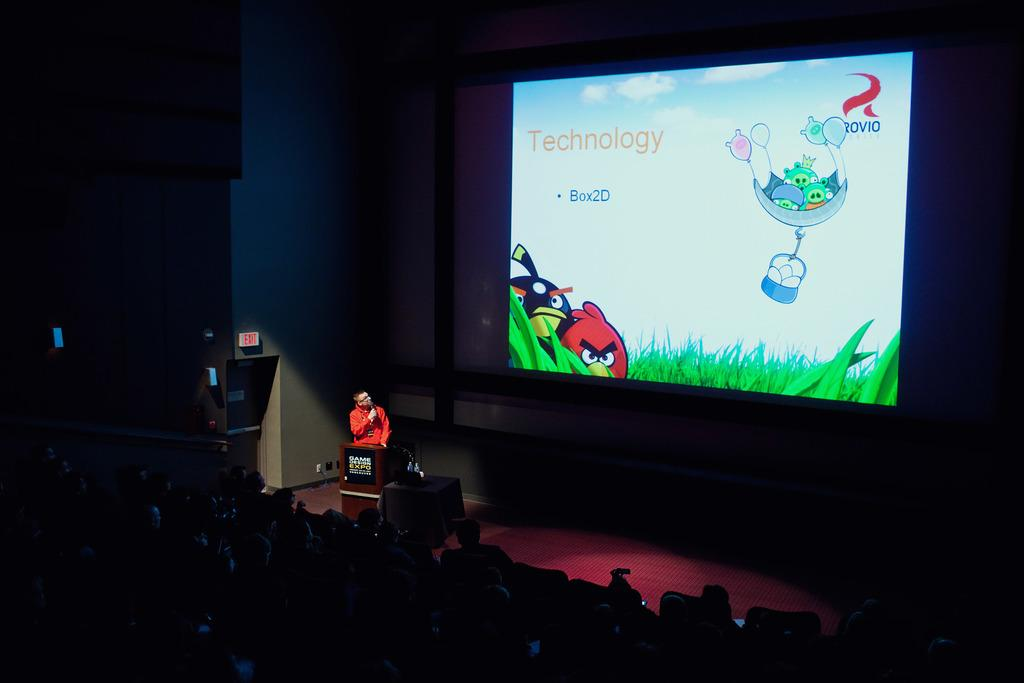<image>
Summarize the visual content of the image. The technology of the Box2D is shown with an Angry Birds theme. 